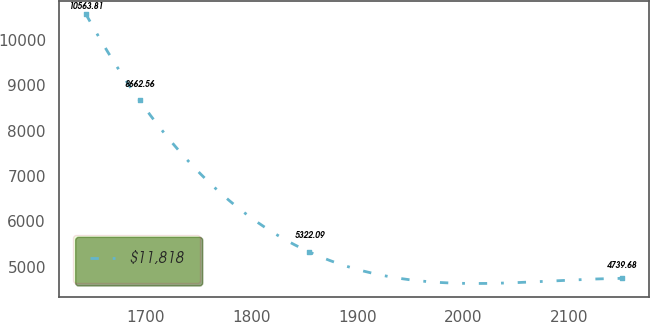<chart> <loc_0><loc_0><loc_500><loc_500><line_chart><ecel><fcel>$11,818<nl><fcel>1643.3<fcel>10563.8<nl><fcel>1693.99<fcel>8662.56<nl><fcel>1854.41<fcel>5322.09<nl><fcel>2150.22<fcel>4739.68<nl></chart> 